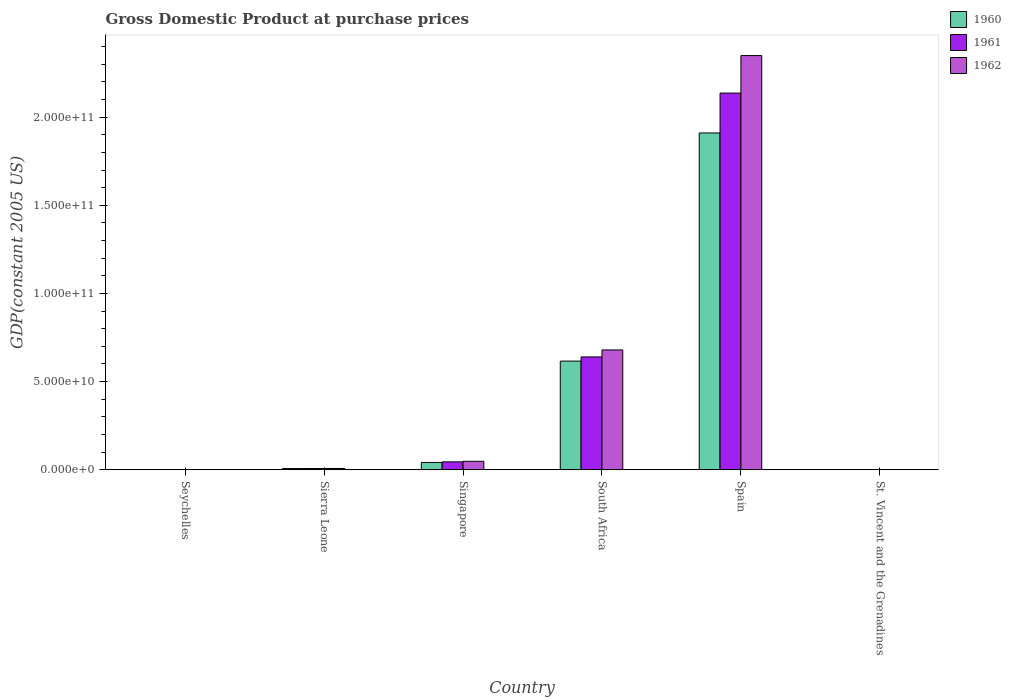How many different coloured bars are there?
Offer a very short reply. 3. How many groups of bars are there?
Your answer should be compact. 6. Are the number of bars on each tick of the X-axis equal?
Ensure brevity in your answer.  Yes. How many bars are there on the 1st tick from the right?
Your answer should be very brief. 3. What is the label of the 3rd group of bars from the left?
Keep it short and to the point. Singapore. What is the GDP at purchase prices in 1961 in Spain?
Ensure brevity in your answer.  2.14e+11. Across all countries, what is the maximum GDP at purchase prices in 1960?
Make the answer very short. 1.91e+11. Across all countries, what is the minimum GDP at purchase prices in 1960?
Keep it short and to the point. 1.23e+08. In which country was the GDP at purchase prices in 1962 maximum?
Offer a very short reply. Spain. In which country was the GDP at purchase prices in 1960 minimum?
Make the answer very short. St. Vincent and the Grenadines. What is the total GDP at purchase prices in 1960 in the graph?
Ensure brevity in your answer.  2.58e+11. What is the difference between the GDP at purchase prices in 1962 in South Africa and that in Spain?
Ensure brevity in your answer.  -1.67e+11. What is the difference between the GDP at purchase prices in 1962 in Spain and the GDP at purchase prices in 1961 in Seychelles?
Your response must be concise. 2.35e+11. What is the average GDP at purchase prices in 1961 per country?
Give a very brief answer. 4.72e+1. What is the difference between the GDP at purchase prices of/in 1961 and GDP at purchase prices of/in 1962 in South Africa?
Ensure brevity in your answer.  -3.95e+09. What is the ratio of the GDP at purchase prices in 1961 in Sierra Leone to that in Singapore?
Your answer should be very brief. 0.16. Is the GDP at purchase prices in 1962 in Seychelles less than that in South Africa?
Give a very brief answer. Yes. Is the difference between the GDP at purchase prices in 1961 in Sierra Leone and Singapore greater than the difference between the GDP at purchase prices in 1962 in Sierra Leone and Singapore?
Provide a short and direct response. Yes. What is the difference between the highest and the second highest GDP at purchase prices in 1960?
Offer a very short reply. -1.29e+11. What is the difference between the highest and the lowest GDP at purchase prices in 1962?
Ensure brevity in your answer.  2.35e+11. What does the 1st bar from the left in St. Vincent and the Grenadines represents?
Provide a short and direct response. 1960. What does the 2nd bar from the right in Seychelles represents?
Make the answer very short. 1961. Is it the case that in every country, the sum of the GDP at purchase prices in 1960 and GDP at purchase prices in 1962 is greater than the GDP at purchase prices in 1961?
Make the answer very short. Yes. How many bars are there?
Provide a short and direct response. 18. What is the difference between two consecutive major ticks on the Y-axis?
Provide a short and direct response. 5.00e+1. Does the graph contain any zero values?
Offer a terse response. No. Where does the legend appear in the graph?
Keep it short and to the point. Top right. What is the title of the graph?
Your response must be concise. Gross Domestic Product at purchase prices. Does "2004" appear as one of the legend labels in the graph?
Offer a very short reply. No. What is the label or title of the X-axis?
Offer a terse response. Country. What is the label or title of the Y-axis?
Your response must be concise. GDP(constant 2005 US). What is the GDP(constant 2005 US) of 1960 in Seychelles?
Offer a terse response. 1.39e+08. What is the GDP(constant 2005 US) of 1961 in Seychelles?
Provide a succinct answer. 1.32e+08. What is the GDP(constant 2005 US) in 1962 in Seychelles?
Make the answer very short. 1.43e+08. What is the GDP(constant 2005 US) in 1960 in Sierra Leone?
Give a very brief answer. 7.13e+08. What is the GDP(constant 2005 US) in 1961 in Sierra Leone?
Provide a short and direct response. 7.25e+08. What is the GDP(constant 2005 US) in 1962 in Sierra Leone?
Provide a short and direct response. 7.58e+08. What is the GDP(constant 2005 US) in 1960 in Singapore?
Provide a short and direct response. 4.17e+09. What is the GDP(constant 2005 US) of 1961 in Singapore?
Keep it short and to the point. 4.50e+09. What is the GDP(constant 2005 US) of 1962 in Singapore?
Offer a very short reply. 4.82e+09. What is the GDP(constant 2005 US) of 1960 in South Africa?
Your answer should be compact. 6.16e+1. What is the GDP(constant 2005 US) in 1961 in South Africa?
Make the answer very short. 6.40e+1. What is the GDP(constant 2005 US) in 1962 in South Africa?
Provide a short and direct response. 6.80e+1. What is the GDP(constant 2005 US) of 1960 in Spain?
Your response must be concise. 1.91e+11. What is the GDP(constant 2005 US) in 1961 in Spain?
Give a very brief answer. 2.14e+11. What is the GDP(constant 2005 US) of 1962 in Spain?
Offer a very short reply. 2.35e+11. What is the GDP(constant 2005 US) of 1960 in St. Vincent and the Grenadines?
Provide a succinct answer. 1.23e+08. What is the GDP(constant 2005 US) of 1961 in St. Vincent and the Grenadines?
Your response must be concise. 1.28e+08. What is the GDP(constant 2005 US) of 1962 in St. Vincent and the Grenadines?
Make the answer very short. 1.33e+08. Across all countries, what is the maximum GDP(constant 2005 US) of 1960?
Ensure brevity in your answer.  1.91e+11. Across all countries, what is the maximum GDP(constant 2005 US) of 1961?
Make the answer very short. 2.14e+11. Across all countries, what is the maximum GDP(constant 2005 US) in 1962?
Provide a short and direct response. 2.35e+11. Across all countries, what is the minimum GDP(constant 2005 US) of 1960?
Your response must be concise. 1.23e+08. Across all countries, what is the minimum GDP(constant 2005 US) of 1961?
Give a very brief answer. 1.28e+08. Across all countries, what is the minimum GDP(constant 2005 US) in 1962?
Provide a short and direct response. 1.33e+08. What is the total GDP(constant 2005 US) of 1960 in the graph?
Offer a very short reply. 2.58e+11. What is the total GDP(constant 2005 US) of 1961 in the graph?
Give a very brief answer. 2.83e+11. What is the total GDP(constant 2005 US) in 1962 in the graph?
Keep it short and to the point. 3.09e+11. What is the difference between the GDP(constant 2005 US) in 1960 in Seychelles and that in Sierra Leone?
Keep it short and to the point. -5.74e+08. What is the difference between the GDP(constant 2005 US) of 1961 in Seychelles and that in Sierra Leone?
Make the answer very short. -5.94e+08. What is the difference between the GDP(constant 2005 US) in 1962 in Seychelles and that in Sierra Leone?
Provide a succinct answer. -6.16e+08. What is the difference between the GDP(constant 2005 US) in 1960 in Seychelles and that in Singapore?
Make the answer very short. -4.03e+09. What is the difference between the GDP(constant 2005 US) of 1961 in Seychelles and that in Singapore?
Your response must be concise. -4.37e+09. What is the difference between the GDP(constant 2005 US) in 1962 in Seychelles and that in Singapore?
Your response must be concise. -4.68e+09. What is the difference between the GDP(constant 2005 US) in 1960 in Seychelles and that in South Africa?
Make the answer very short. -6.15e+1. What is the difference between the GDP(constant 2005 US) in 1961 in Seychelles and that in South Africa?
Offer a very short reply. -6.39e+1. What is the difference between the GDP(constant 2005 US) of 1962 in Seychelles and that in South Africa?
Your answer should be very brief. -6.78e+1. What is the difference between the GDP(constant 2005 US) of 1960 in Seychelles and that in Spain?
Your answer should be very brief. -1.91e+11. What is the difference between the GDP(constant 2005 US) in 1961 in Seychelles and that in Spain?
Provide a short and direct response. -2.13e+11. What is the difference between the GDP(constant 2005 US) of 1962 in Seychelles and that in Spain?
Offer a very short reply. -2.35e+11. What is the difference between the GDP(constant 2005 US) in 1960 in Seychelles and that in St. Vincent and the Grenadines?
Provide a short and direct response. 1.58e+07. What is the difference between the GDP(constant 2005 US) in 1961 in Seychelles and that in St. Vincent and the Grenadines?
Your answer should be compact. 3.51e+06. What is the difference between the GDP(constant 2005 US) of 1962 in Seychelles and that in St. Vincent and the Grenadines?
Provide a short and direct response. 9.85e+06. What is the difference between the GDP(constant 2005 US) of 1960 in Sierra Leone and that in Singapore?
Offer a terse response. -3.45e+09. What is the difference between the GDP(constant 2005 US) in 1961 in Sierra Leone and that in Singapore?
Offer a terse response. -3.78e+09. What is the difference between the GDP(constant 2005 US) of 1962 in Sierra Leone and that in Singapore?
Give a very brief answer. -4.07e+09. What is the difference between the GDP(constant 2005 US) in 1960 in Sierra Leone and that in South Africa?
Offer a terse response. -6.09e+1. What is the difference between the GDP(constant 2005 US) in 1961 in Sierra Leone and that in South Africa?
Your answer should be very brief. -6.33e+1. What is the difference between the GDP(constant 2005 US) in 1962 in Sierra Leone and that in South Africa?
Keep it short and to the point. -6.72e+1. What is the difference between the GDP(constant 2005 US) of 1960 in Sierra Leone and that in Spain?
Your answer should be very brief. -1.90e+11. What is the difference between the GDP(constant 2005 US) of 1961 in Sierra Leone and that in Spain?
Provide a short and direct response. -2.13e+11. What is the difference between the GDP(constant 2005 US) of 1962 in Sierra Leone and that in Spain?
Offer a very short reply. -2.34e+11. What is the difference between the GDP(constant 2005 US) of 1960 in Sierra Leone and that in St. Vincent and the Grenadines?
Offer a terse response. 5.90e+08. What is the difference between the GDP(constant 2005 US) of 1961 in Sierra Leone and that in St. Vincent and the Grenadines?
Keep it short and to the point. 5.97e+08. What is the difference between the GDP(constant 2005 US) of 1962 in Sierra Leone and that in St. Vincent and the Grenadines?
Ensure brevity in your answer.  6.25e+08. What is the difference between the GDP(constant 2005 US) of 1960 in Singapore and that in South Africa?
Keep it short and to the point. -5.75e+1. What is the difference between the GDP(constant 2005 US) of 1961 in Singapore and that in South Africa?
Your answer should be very brief. -5.95e+1. What is the difference between the GDP(constant 2005 US) in 1962 in Singapore and that in South Africa?
Offer a very short reply. -6.31e+1. What is the difference between the GDP(constant 2005 US) in 1960 in Singapore and that in Spain?
Provide a succinct answer. -1.87e+11. What is the difference between the GDP(constant 2005 US) in 1961 in Singapore and that in Spain?
Provide a short and direct response. -2.09e+11. What is the difference between the GDP(constant 2005 US) of 1962 in Singapore and that in Spain?
Your response must be concise. -2.30e+11. What is the difference between the GDP(constant 2005 US) of 1960 in Singapore and that in St. Vincent and the Grenadines?
Offer a very short reply. 4.04e+09. What is the difference between the GDP(constant 2005 US) of 1961 in Singapore and that in St. Vincent and the Grenadines?
Make the answer very short. 4.38e+09. What is the difference between the GDP(constant 2005 US) in 1962 in Singapore and that in St. Vincent and the Grenadines?
Your response must be concise. 4.69e+09. What is the difference between the GDP(constant 2005 US) of 1960 in South Africa and that in Spain?
Offer a terse response. -1.29e+11. What is the difference between the GDP(constant 2005 US) in 1961 in South Africa and that in Spain?
Ensure brevity in your answer.  -1.50e+11. What is the difference between the GDP(constant 2005 US) in 1962 in South Africa and that in Spain?
Ensure brevity in your answer.  -1.67e+11. What is the difference between the GDP(constant 2005 US) of 1960 in South Africa and that in St. Vincent and the Grenadines?
Offer a terse response. 6.15e+1. What is the difference between the GDP(constant 2005 US) of 1961 in South Africa and that in St. Vincent and the Grenadines?
Offer a very short reply. 6.39e+1. What is the difference between the GDP(constant 2005 US) in 1962 in South Africa and that in St. Vincent and the Grenadines?
Ensure brevity in your answer.  6.78e+1. What is the difference between the GDP(constant 2005 US) in 1960 in Spain and that in St. Vincent and the Grenadines?
Your response must be concise. 1.91e+11. What is the difference between the GDP(constant 2005 US) in 1961 in Spain and that in St. Vincent and the Grenadines?
Your answer should be compact. 2.13e+11. What is the difference between the GDP(constant 2005 US) of 1962 in Spain and that in St. Vincent and the Grenadines?
Your answer should be very brief. 2.35e+11. What is the difference between the GDP(constant 2005 US) in 1960 in Seychelles and the GDP(constant 2005 US) in 1961 in Sierra Leone?
Make the answer very short. -5.87e+08. What is the difference between the GDP(constant 2005 US) in 1960 in Seychelles and the GDP(constant 2005 US) in 1962 in Sierra Leone?
Ensure brevity in your answer.  -6.20e+08. What is the difference between the GDP(constant 2005 US) of 1961 in Seychelles and the GDP(constant 2005 US) of 1962 in Sierra Leone?
Keep it short and to the point. -6.27e+08. What is the difference between the GDP(constant 2005 US) of 1960 in Seychelles and the GDP(constant 2005 US) of 1961 in Singapore?
Offer a terse response. -4.37e+09. What is the difference between the GDP(constant 2005 US) of 1960 in Seychelles and the GDP(constant 2005 US) of 1962 in Singapore?
Your answer should be very brief. -4.69e+09. What is the difference between the GDP(constant 2005 US) of 1961 in Seychelles and the GDP(constant 2005 US) of 1962 in Singapore?
Make the answer very short. -4.69e+09. What is the difference between the GDP(constant 2005 US) of 1960 in Seychelles and the GDP(constant 2005 US) of 1961 in South Africa?
Make the answer very short. -6.39e+1. What is the difference between the GDP(constant 2005 US) in 1960 in Seychelles and the GDP(constant 2005 US) in 1962 in South Africa?
Give a very brief answer. -6.78e+1. What is the difference between the GDP(constant 2005 US) in 1961 in Seychelles and the GDP(constant 2005 US) in 1962 in South Africa?
Give a very brief answer. -6.78e+1. What is the difference between the GDP(constant 2005 US) in 1960 in Seychelles and the GDP(constant 2005 US) in 1961 in Spain?
Keep it short and to the point. -2.13e+11. What is the difference between the GDP(constant 2005 US) in 1960 in Seychelles and the GDP(constant 2005 US) in 1962 in Spain?
Give a very brief answer. -2.35e+11. What is the difference between the GDP(constant 2005 US) of 1961 in Seychelles and the GDP(constant 2005 US) of 1962 in Spain?
Ensure brevity in your answer.  -2.35e+11. What is the difference between the GDP(constant 2005 US) of 1960 in Seychelles and the GDP(constant 2005 US) of 1961 in St. Vincent and the Grenadines?
Make the answer very short. 1.03e+07. What is the difference between the GDP(constant 2005 US) in 1960 in Seychelles and the GDP(constant 2005 US) in 1962 in St. Vincent and the Grenadines?
Ensure brevity in your answer.  5.53e+06. What is the difference between the GDP(constant 2005 US) of 1961 in Seychelles and the GDP(constant 2005 US) of 1962 in St. Vincent and the Grenadines?
Provide a succinct answer. -1.23e+06. What is the difference between the GDP(constant 2005 US) of 1960 in Sierra Leone and the GDP(constant 2005 US) of 1961 in Singapore?
Keep it short and to the point. -3.79e+09. What is the difference between the GDP(constant 2005 US) of 1960 in Sierra Leone and the GDP(constant 2005 US) of 1962 in Singapore?
Your response must be concise. -4.11e+09. What is the difference between the GDP(constant 2005 US) in 1961 in Sierra Leone and the GDP(constant 2005 US) in 1962 in Singapore?
Your response must be concise. -4.10e+09. What is the difference between the GDP(constant 2005 US) of 1960 in Sierra Leone and the GDP(constant 2005 US) of 1961 in South Africa?
Your response must be concise. -6.33e+1. What is the difference between the GDP(constant 2005 US) of 1960 in Sierra Leone and the GDP(constant 2005 US) of 1962 in South Africa?
Provide a short and direct response. -6.73e+1. What is the difference between the GDP(constant 2005 US) of 1961 in Sierra Leone and the GDP(constant 2005 US) of 1962 in South Africa?
Your response must be concise. -6.72e+1. What is the difference between the GDP(constant 2005 US) of 1960 in Sierra Leone and the GDP(constant 2005 US) of 1961 in Spain?
Ensure brevity in your answer.  -2.13e+11. What is the difference between the GDP(constant 2005 US) in 1960 in Sierra Leone and the GDP(constant 2005 US) in 1962 in Spain?
Your answer should be compact. -2.34e+11. What is the difference between the GDP(constant 2005 US) in 1961 in Sierra Leone and the GDP(constant 2005 US) in 1962 in Spain?
Keep it short and to the point. -2.34e+11. What is the difference between the GDP(constant 2005 US) of 1960 in Sierra Leone and the GDP(constant 2005 US) of 1961 in St. Vincent and the Grenadines?
Offer a very short reply. 5.84e+08. What is the difference between the GDP(constant 2005 US) of 1960 in Sierra Leone and the GDP(constant 2005 US) of 1962 in St. Vincent and the Grenadines?
Make the answer very short. 5.80e+08. What is the difference between the GDP(constant 2005 US) of 1961 in Sierra Leone and the GDP(constant 2005 US) of 1962 in St. Vincent and the Grenadines?
Your response must be concise. 5.93e+08. What is the difference between the GDP(constant 2005 US) of 1960 in Singapore and the GDP(constant 2005 US) of 1961 in South Africa?
Your response must be concise. -5.98e+1. What is the difference between the GDP(constant 2005 US) of 1960 in Singapore and the GDP(constant 2005 US) of 1962 in South Africa?
Offer a very short reply. -6.38e+1. What is the difference between the GDP(constant 2005 US) in 1961 in Singapore and the GDP(constant 2005 US) in 1962 in South Africa?
Provide a short and direct response. -6.35e+1. What is the difference between the GDP(constant 2005 US) of 1960 in Singapore and the GDP(constant 2005 US) of 1961 in Spain?
Your answer should be very brief. -2.09e+11. What is the difference between the GDP(constant 2005 US) of 1960 in Singapore and the GDP(constant 2005 US) of 1962 in Spain?
Provide a succinct answer. -2.31e+11. What is the difference between the GDP(constant 2005 US) of 1961 in Singapore and the GDP(constant 2005 US) of 1962 in Spain?
Your answer should be compact. -2.30e+11. What is the difference between the GDP(constant 2005 US) of 1960 in Singapore and the GDP(constant 2005 US) of 1961 in St. Vincent and the Grenadines?
Keep it short and to the point. 4.04e+09. What is the difference between the GDP(constant 2005 US) of 1960 in Singapore and the GDP(constant 2005 US) of 1962 in St. Vincent and the Grenadines?
Give a very brief answer. 4.03e+09. What is the difference between the GDP(constant 2005 US) of 1961 in Singapore and the GDP(constant 2005 US) of 1962 in St. Vincent and the Grenadines?
Your answer should be very brief. 4.37e+09. What is the difference between the GDP(constant 2005 US) in 1960 in South Africa and the GDP(constant 2005 US) in 1961 in Spain?
Give a very brief answer. -1.52e+11. What is the difference between the GDP(constant 2005 US) in 1960 in South Africa and the GDP(constant 2005 US) in 1962 in Spain?
Give a very brief answer. -1.73e+11. What is the difference between the GDP(constant 2005 US) of 1961 in South Africa and the GDP(constant 2005 US) of 1962 in Spain?
Make the answer very short. -1.71e+11. What is the difference between the GDP(constant 2005 US) of 1960 in South Africa and the GDP(constant 2005 US) of 1961 in St. Vincent and the Grenadines?
Offer a terse response. 6.15e+1. What is the difference between the GDP(constant 2005 US) of 1960 in South Africa and the GDP(constant 2005 US) of 1962 in St. Vincent and the Grenadines?
Offer a terse response. 6.15e+1. What is the difference between the GDP(constant 2005 US) of 1961 in South Africa and the GDP(constant 2005 US) of 1962 in St. Vincent and the Grenadines?
Your response must be concise. 6.39e+1. What is the difference between the GDP(constant 2005 US) in 1960 in Spain and the GDP(constant 2005 US) in 1961 in St. Vincent and the Grenadines?
Ensure brevity in your answer.  1.91e+11. What is the difference between the GDP(constant 2005 US) in 1960 in Spain and the GDP(constant 2005 US) in 1962 in St. Vincent and the Grenadines?
Ensure brevity in your answer.  1.91e+11. What is the difference between the GDP(constant 2005 US) in 1961 in Spain and the GDP(constant 2005 US) in 1962 in St. Vincent and the Grenadines?
Your answer should be compact. 2.13e+11. What is the average GDP(constant 2005 US) of 1960 per country?
Provide a succinct answer. 4.30e+1. What is the average GDP(constant 2005 US) of 1961 per country?
Your answer should be compact. 4.72e+1. What is the average GDP(constant 2005 US) of 1962 per country?
Keep it short and to the point. 5.15e+1. What is the difference between the GDP(constant 2005 US) in 1960 and GDP(constant 2005 US) in 1961 in Seychelles?
Your answer should be very brief. 6.76e+06. What is the difference between the GDP(constant 2005 US) of 1960 and GDP(constant 2005 US) of 1962 in Seychelles?
Provide a succinct answer. -4.32e+06. What is the difference between the GDP(constant 2005 US) in 1961 and GDP(constant 2005 US) in 1962 in Seychelles?
Your response must be concise. -1.11e+07. What is the difference between the GDP(constant 2005 US) in 1960 and GDP(constant 2005 US) in 1961 in Sierra Leone?
Keep it short and to the point. -1.29e+07. What is the difference between the GDP(constant 2005 US) of 1960 and GDP(constant 2005 US) of 1962 in Sierra Leone?
Your answer should be very brief. -4.58e+07. What is the difference between the GDP(constant 2005 US) of 1961 and GDP(constant 2005 US) of 1962 in Sierra Leone?
Offer a terse response. -3.29e+07. What is the difference between the GDP(constant 2005 US) of 1960 and GDP(constant 2005 US) of 1961 in Singapore?
Keep it short and to the point. -3.39e+08. What is the difference between the GDP(constant 2005 US) of 1960 and GDP(constant 2005 US) of 1962 in Singapore?
Offer a terse response. -6.60e+08. What is the difference between the GDP(constant 2005 US) in 1961 and GDP(constant 2005 US) in 1962 in Singapore?
Provide a short and direct response. -3.21e+08. What is the difference between the GDP(constant 2005 US) of 1960 and GDP(constant 2005 US) of 1961 in South Africa?
Give a very brief answer. -2.37e+09. What is the difference between the GDP(constant 2005 US) of 1960 and GDP(constant 2005 US) of 1962 in South Africa?
Offer a terse response. -6.32e+09. What is the difference between the GDP(constant 2005 US) of 1961 and GDP(constant 2005 US) of 1962 in South Africa?
Give a very brief answer. -3.95e+09. What is the difference between the GDP(constant 2005 US) in 1960 and GDP(constant 2005 US) in 1961 in Spain?
Your answer should be compact. -2.26e+1. What is the difference between the GDP(constant 2005 US) of 1960 and GDP(constant 2005 US) of 1962 in Spain?
Provide a short and direct response. -4.39e+1. What is the difference between the GDP(constant 2005 US) in 1961 and GDP(constant 2005 US) in 1962 in Spain?
Offer a terse response. -2.13e+1. What is the difference between the GDP(constant 2005 US) of 1960 and GDP(constant 2005 US) of 1961 in St. Vincent and the Grenadines?
Give a very brief answer. -5.55e+06. What is the difference between the GDP(constant 2005 US) in 1960 and GDP(constant 2005 US) in 1962 in St. Vincent and the Grenadines?
Your answer should be very brief. -1.03e+07. What is the difference between the GDP(constant 2005 US) in 1961 and GDP(constant 2005 US) in 1962 in St. Vincent and the Grenadines?
Your answer should be compact. -4.74e+06. What is the ratio of the GDP(constant 2005 US) in 1960 in Seychelles to that in Sierra Leone?
Your answer should be compact. 0.19. What is the ratio of the GDP(constant 2005 US) of 1961 in Seychelles to that in Sierra Leone?
Keep it short and to the point. 0.18. What is the ratio of the GDP(constant 2005 US) of 1962 in Seychelles to that in Sierra Leone?
Your answer should be very brief. 0.19. What is the ratio of the GDP(constant 2005 US) of 1961 in Seychelles to that in Singapore?
Offer a very short reply. 0.03. What is the ratio of the GDP(constant 2005 US) of 1962 in Seychelles to that in Singapore?
Make the answer very short. 0.03. What is the ratio of the GDP(constant 2005 US) in 1960 in Seychelles to that in South Africa?
Your answer should be compact. 0. What is the ratio of the GDP(constant 2005 US) in 1961 in Seychelles to that in South Africa?
Your answer should be very brief. 0. What is the ratio of the GDP(constant 2005 US) of 1962 in Seychelles to that in South Africa?
Ensure brevity in your answer.  0. What is the ratio of the GDP(constant 2005 US) in 1960 in Seychelles to that in Spain?
Offer a very short reply. 0. What is the ratio of the GDP(constant 2005 US) in 1961 in Seychelles to that in Spain?
Make the answer very short. 0. What is the ratio of the GDP(constant 2005 US) of 1962 in Seychelles to that in Spain?
Provide a succinct answer. 0. What is the ratio of the GDP(constant 2005 US) of 1960 in Seychelles to that in St. Vincent and the Grenadines?
Offer a terse response. 1.13. What is the ratio of the GDP(constant 2005 US) in 1961 in Seychelles to that in St. Vincent and the Grenadines?
Offer a terse response. 1.03. What is the ratio of the GDP(constant 2005 US) in 1962 in Seychelles to that in St. Vincent and the Grenadines?
Make the answer very short. 1.07. What is the ratio of the GDP(constant 2005 US) of 1960 in Sierra Leone to that in Singapore?
Your response must be concise. 0.17. What is the ratio of the GDP(constant 2005 US) of 1961 in Sierra Leone to that in Singapore?
Provide a succinct answer. 0.16. What is the ratio of the GDP(constant 2005 US) of 1962 in Sierra Leone to that in Singapore?
Provide a succinct answer. 0.16. What is the ratio of the GDP(constant 2005 US) of 1960 in Sierra Leone to that in South Africa?
Your answer should be compact. 0.01. What is the ratio of the GDP(constant 2005 US) of 1961 in Sierra Leone to that in South Africa?
Keep it short and to the point. 0.01. What is the ratio of the GDP(constant 2005 US) in 1962 in Sierra Leone to that in South Africa?
Keep it short and to the point. 0.01. What is the ratio of the GDP(constant 2005 US) of 1960 in Sierra Leone to that in Spain?
Provide a short and direct response. 0. What is the ratio of the GDP(constant 2005 US) in 1961 in Sierra Leone to that in Spain?
Your answer should be very brief. 0. What is the ratio of the GDP(constant 2005 US) of 1962 in Sierra Leone to that in Spain?
Provide a succinct answer. 0. What is the ratio of the GDP(constant 2005 US) of 1960 in Sierra Leone to that in St. Vincent and the Grenadines?
Your answer should be very brief. 5.81. What is the ratio of the GDP(constant 2005 US) in 1961 in Sierra Leone to that in St. Vincent and the Grenadines?
Offer a terse response. 5.66. What is the ratio of the GDP(constant 2005 US) in 1962 in Sierra Leone to that in St. Vincent and the Grenadines?
Your response must be concise. 5.7. What is the ratio of the GDP(constant 2005 US) of 1960 in Singapore to that in South Africa?
Your response must be concise. 0.07. What is the ratio of the GDP(constant 2005 US) of 1961 in Singapore to that in South Africa?
Offer a terse response. 0.07. What is the ratio of the GDP(constant 2005 US) of 1962 in Singapore to that in South Africa?
Give a very brief answer. 0.07. What is the ratio of the GDP(constant 2005 US) of 1960 in Singapore to that in Spain?
Provide a succinct answer. 0.02. What is the ratio of the GDP(constant 2005 US) of 1961 in Singapore to that in Spain?
Make the answer very short. 0.02. What is the ratio of the GDP(constant 2005 US) of 1962 in Singapore to that in Spain?
Keep it short and to the point. 0.02. What is the ratio of the GDP(constant 2005 US) in 1960 in Singapore to that in St. Vincent and the Grenadines?
Your response must be concise. 33.95. What is the ratio of the GDP(constant 2005 US) in 1961 in Singapore to that in St. Vincent and the Grenadines?
Provide a short and direct response. 35.13. What is the ratio of the GDP(constant 2005 US) of 1962 in Singapore to that in St. Vincent and the Grenadines?
Your response must be concise. 36.29. What is the ratio of the GDP(constant 2005 US) of 1960 in South Africa to that in Spain?
Offer a very short reply. 0.32. What is the ratio of the GDP(constant 2005 US) in 1961 in South Africa to that in Spain?
Give a very brief answer. 0.3. What is the ratio of the GDP(constant 2005 US) in 1962 in South Africa to that in Spain?
Ensure brevity in your answer.  0.29. What is the ratio of the GDP(constant 2005 US) of 1960 in South Africa to that in St. Vincent and the Grenadines?
Give a very brief answer. 502.49. What is the ratio of the GDP(constant 2005 US) in 1961 in South Africa to that in St. Vincent and the Grenadines?
Offer a terse response. 499.21. What is the ratio of the GDP(constant 2005 US) in 1962 in South Africa to that in St. Vincent and the Grenadines?
Ensure brevity in your answer.  511.17. What is the ratio of the GDP(constant 2005 US) of 1960 in Spain to that in St. Vincent and the Grenadines?
Your answer should be very brief. 1557.03. What is the ratio of the GDP(constant 2005 US) of 1961 in Spain to that in St. Vincent and the Grenadines?
Make the answer very short. 1665.94. What is the ratio of the GDP(constant 2005 US) of 1962 in Spain to that in St. Vincent and the Grenadines?
Make the answer very short. 1766.5. What is the difference between the highest and the second highest GDP(constant 2005 US) of 1960?
Provide a short and direct response. 1.29e+11. What is the difference between the highest and the second highest GDP(constant 2005 US) in 1961?
Your answer should be very brief. 1.50e+11. What is the difference between the highest and the second highest GDP(constant 2005 US) of 1962?
Keep it short and to the point. 1.67e+11. What is the difference between the highest and the lowest GDP(constant 2005 US) of 1960?
Make the answer very short. 1.91e+11. What is the difference between the highest and the lowest GDP(constant 2005 US) of 1961?
Give a very brief answer. 2.13e+11. What is the difference between the highest and the lowest GDP(constant 2005 US) in 1962?
Give a very brief answer. 2.35e+11. 